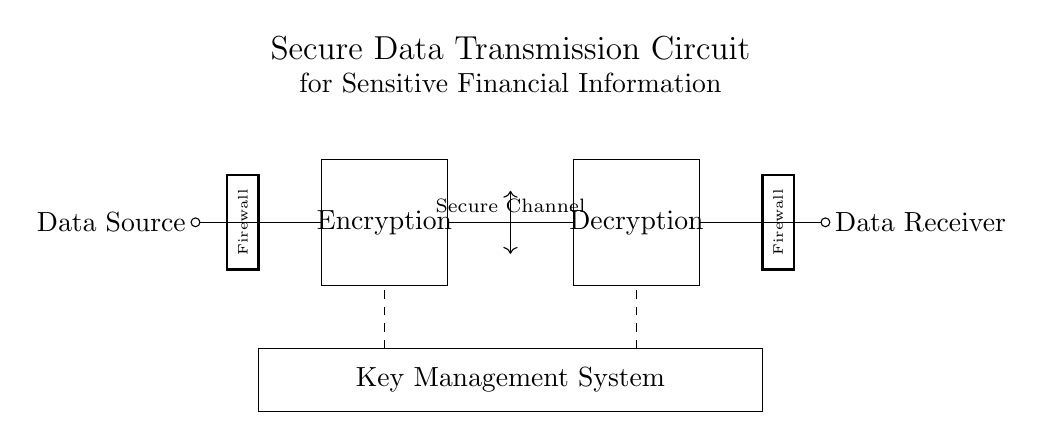What is the primary function of the encryption block? The primary function of the encryption block is to secure sensitive data before it is transmitted, ensuring that it remains confidential during transmission.
Answer: Secure data What does the dashed rectangle represent? The dashed rectangle represents the key management system, which is responsible for managing the cryptographic keys used for encryption and decryption in the circuit.
Answer: Key Management System How many firewalls are present in the circuit? There are two firewalls present in the circuit, one on each end of the data transmission path, providing security at the entry and exit points.
Answer: Two What is the label of the data source in the circuit? The data source in the circuit is labeled as "Data Source," indicating where the sensitive financial information originates before being encrypted.
Answer: Data Source What do the arrows labeled "Secure Channel" signify? The arrows labeled "Secure Channel" signify the transmission path of data after encryption, indicating that the data is securely transmitted from the encryption block to the decryption block.
Answer: Secure transmission Why is a decryption block necessary? The decryption block is necessary to reverse the encryption process, allowing the secure data to be converted back into its original form for the data receiver to access.
Answer: To access original data 